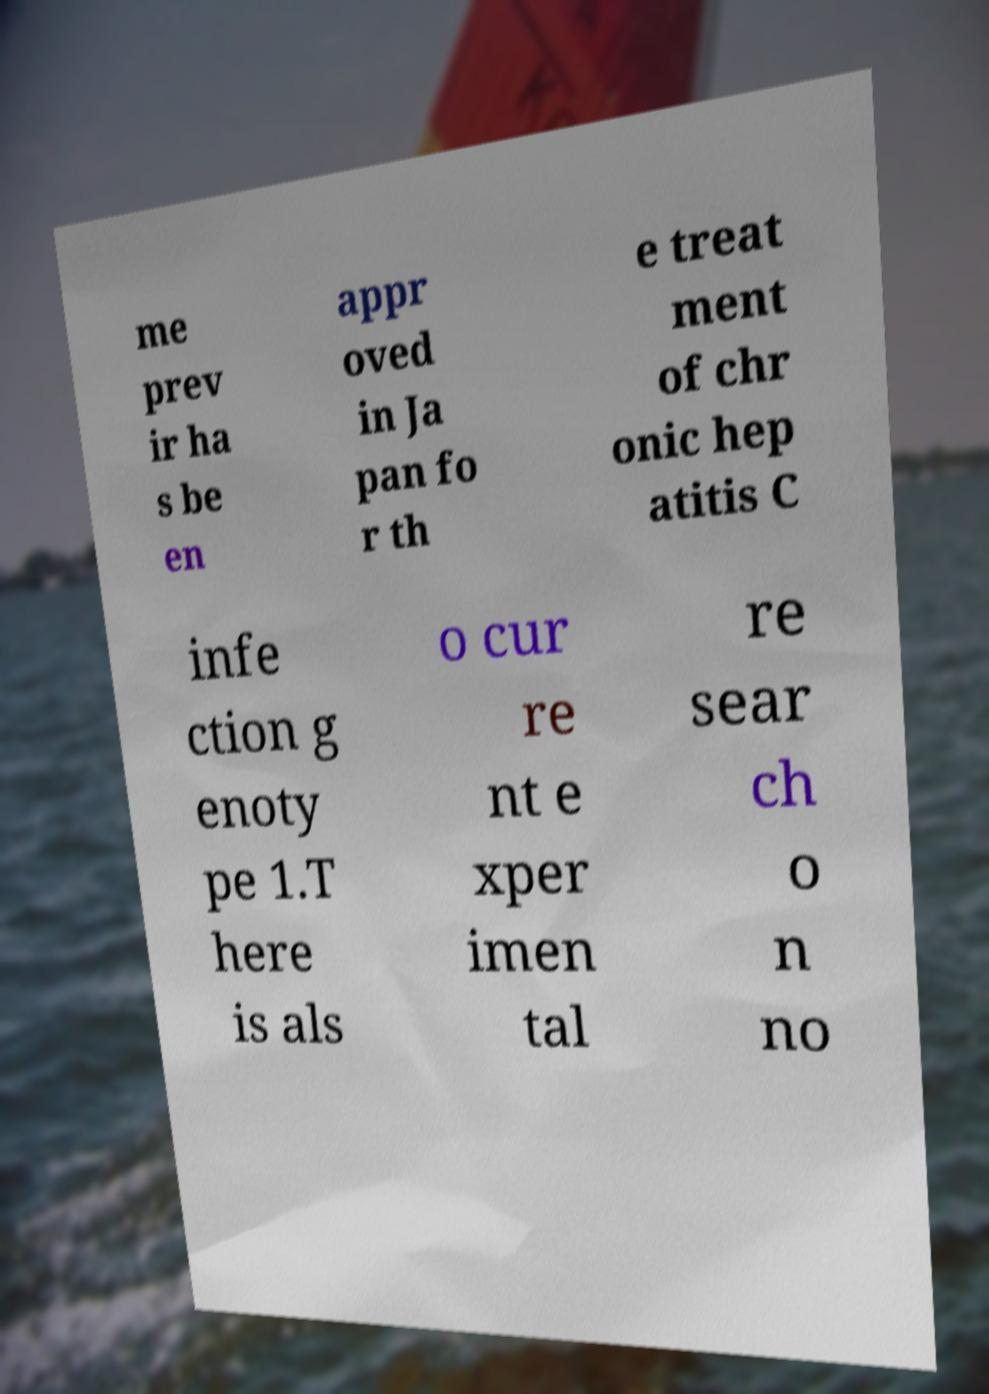Can you read and provide the text displayed in the image?This photo seems to have some interesting text. Can you extract and type it out for me? me prev ir ha s be en appr oved in Ja pan fo r th e treat ment of chr onic hep atitis C infe ction g enoty pe 1.T here is als o cur re nt e xper imen tal re sear ch o n no 